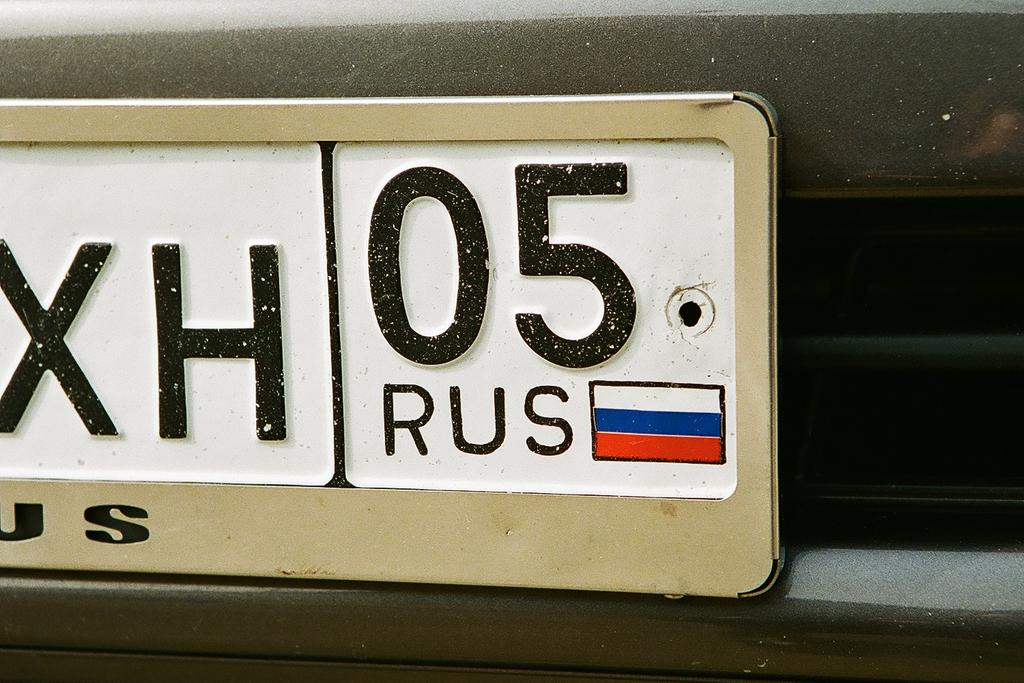<image>
Relay a brief, clear account of the picture shown. a close up of a license plate with XH 05 on it 